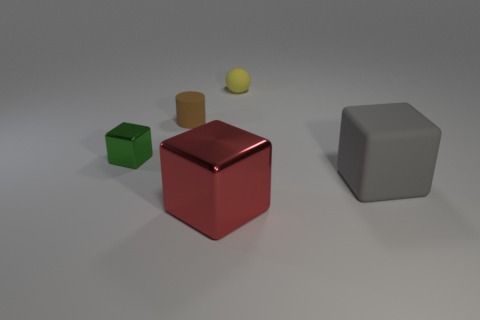There is a rubber object in front of the small green metal object; is there a tiny brown thing that is in front of it?
Give a very brief answer. No. There is a metallic object that is to the left of the brown rubber cylinder; is its size the same as the matte object that is left of the yellow object?
Offer a very short reply. Yes. How many small objects are green blocks or gray matte cubes?
Your answer should be compact. 1. There is a small brown object that is on the left side of the block that is in front of the large matte block; what is it made of?
Provide a succinct answer. Rubber. Are there any tiny brown things that have the same material as the tiny cube?
Provide a succinct answer. No. Does the brown thing have the same material as the big block behind the large metallic cube?
Offer a terse response. Yes. What color is the thing that is the same size as the gray block?
Offer a terse response. Red. There is a gray rubber object that is on the right side of the metallic thing that is behind the red cube; how big is it?
Offer a very short reply. Large. Does the small metallic thing have the same color as the object in front of the big rubber thing?
Keep it short and to the point. No. Is the number of things in front of the brown rubber cylinder less than the number of big blue cylinders?
Give a very brief answer. No. 